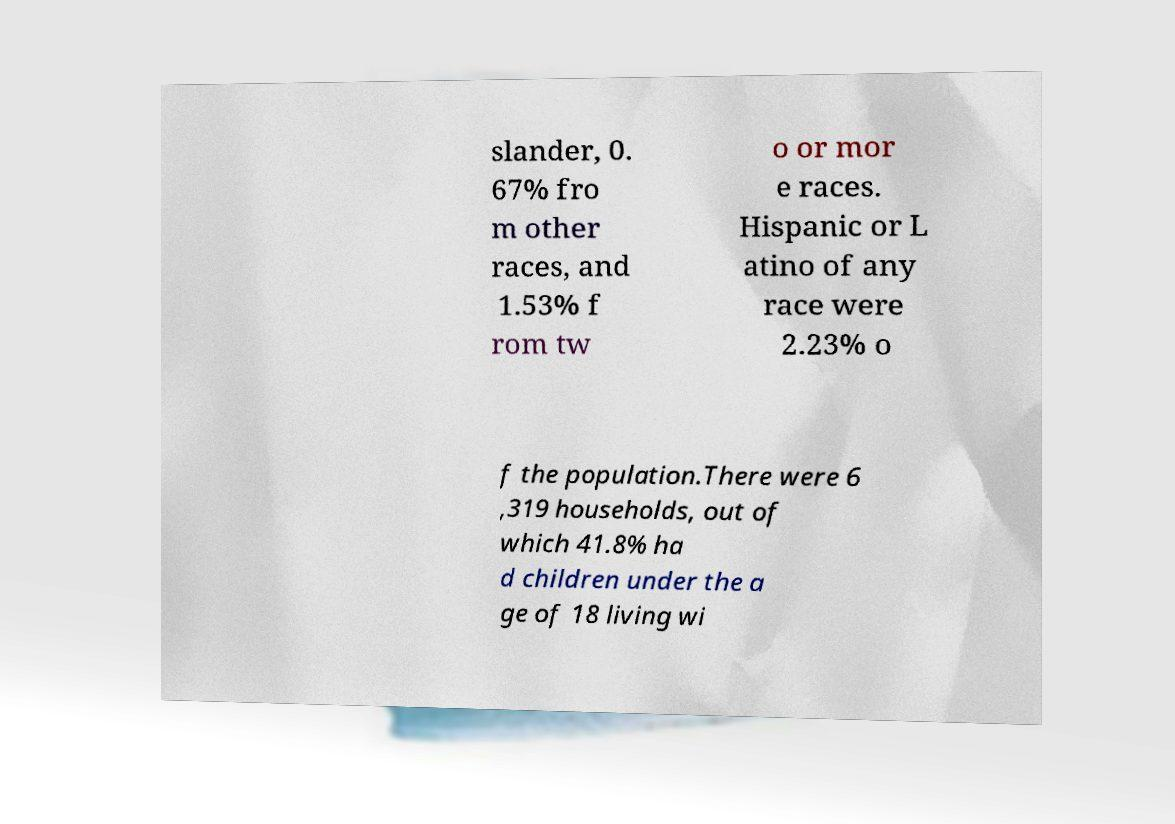I need the written content from this picture converted into text. Can you do that? slander, 0. 67% fro m other races, and 1.53% f rom tw o or mor e races. Hispanic or L atino of any race were 2.23% o f the population.There were 6 ,319 households, out of which 41.8% ha d children under the a ge of 18 living wi 